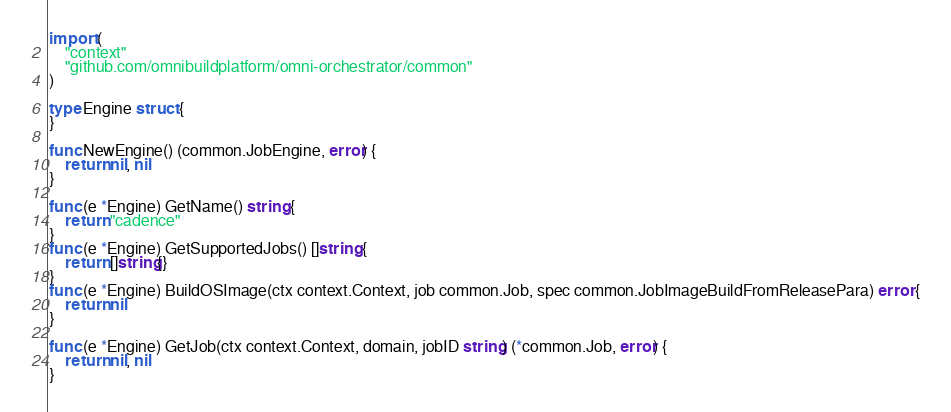Convert code to text. <code><loc_0><loc_0><loc_500><loc_500><_Go_>import (
	"context"
	"github.com/omnibuildplatform/omni-orchestrator/common"
)

type Engine struct {
}

func NewEngine() (common.JobEngine, error) {
	return nil, nil
}

func (e *Engine) GetName() string {
	return "cadence"
}
func (e *Engine) GetSupportedJobs() []string {
	return []string{}
}
func (e *Engine) BuildOSImage(ctx context.Context, job common.Job, spec common.JobImageBuildFromReleasePara) error {
	return nil
}

func (e *Engine) GetJob(ctx context.Context, domain, jobID string) (*common.Job, error) {
	return nil, nil
}
</code> 